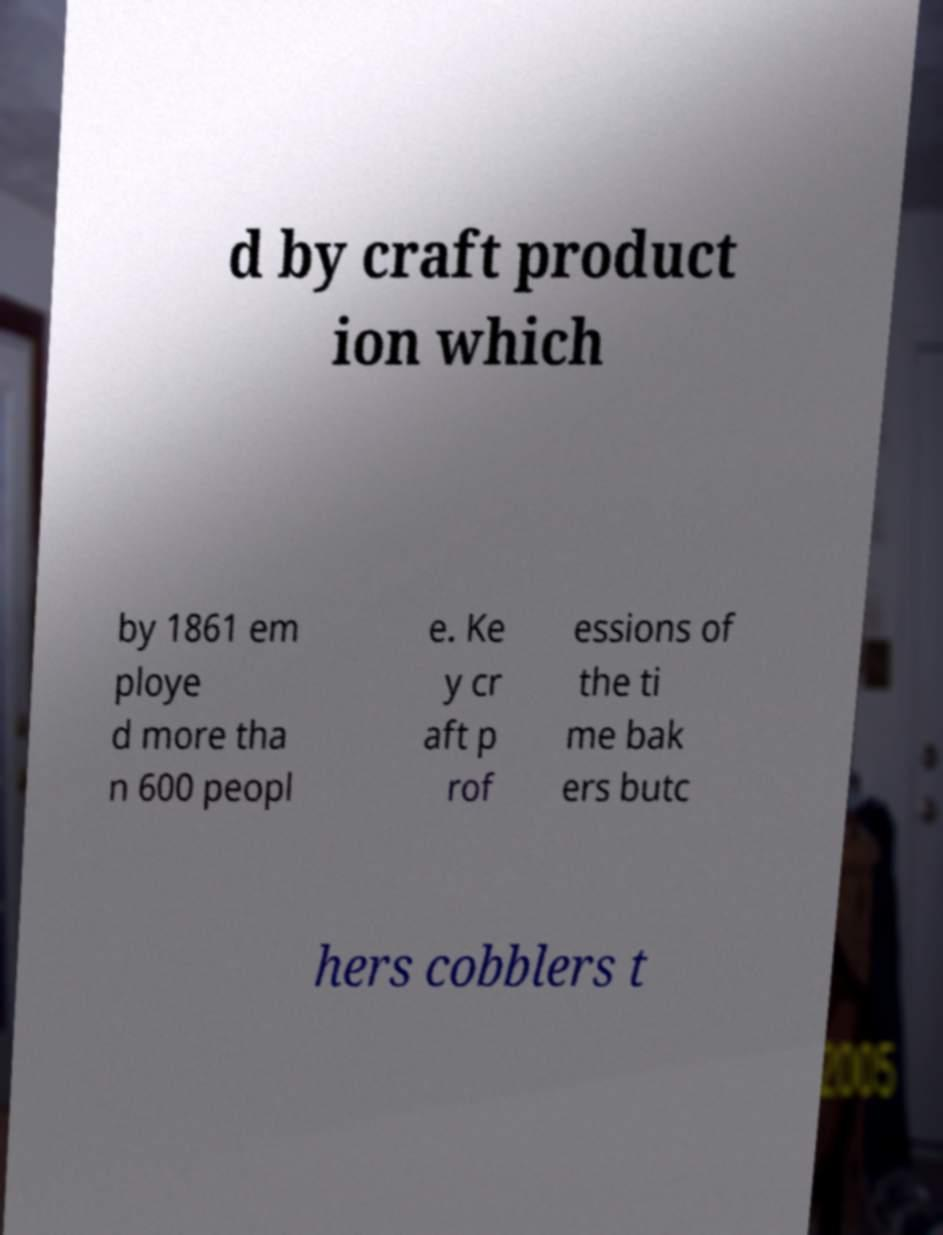For documentation purposes, I need the text within this image transcribed. Could you provide that? d by craft product ion which by 1861 em ploye d more tha n 600 peopl e. Ke y cr aft p rof essions of the ti me bak ers butc hers cobblers t 